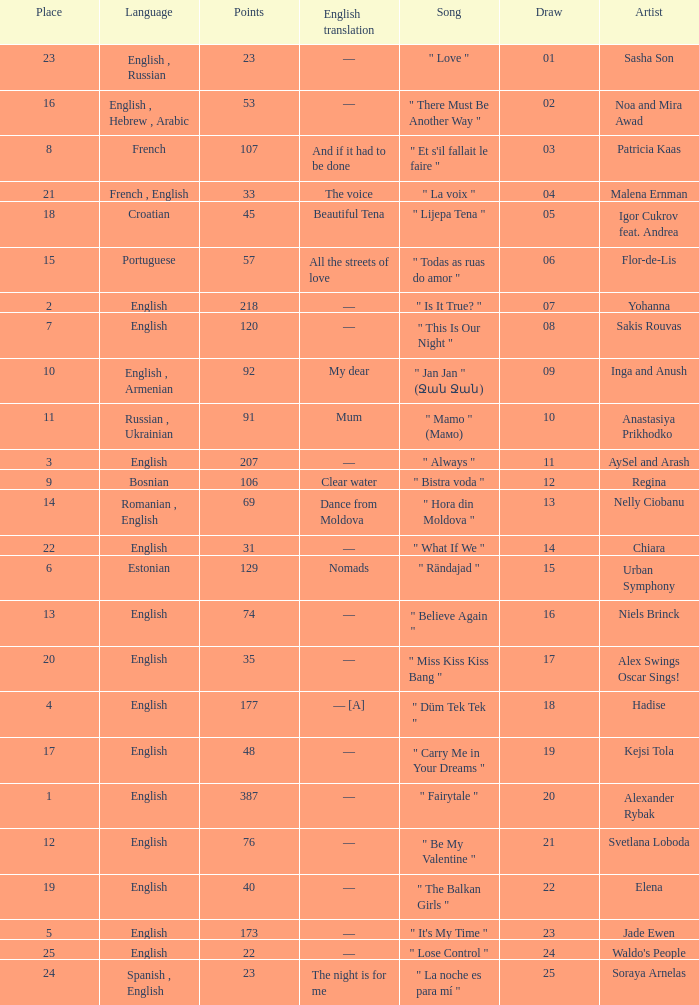Would you be able to parse every entry in this table? {'header': ['Place', 'Language', 'Points', 'English translation', 'Song', 'Draw', 'Artist'], 'rows': [['23', 'English , Russian', '23', '—', '" Love "', '01', 'Sasha Son'], ['16', 'English , Hebrew , Arabic', '53', '—', '" There Must Be Another Way "', '02', 'Noa and Mira Awad'], ['8', 'French', '107', 'And if it had to be done', '" Et s\'il fallait le faire "', '03', 'Patricia Kaas'], ['21', 'French , English', '33', 'The voice', '" La voix "', '04', 'Malena Ernman'], ['18', 'Croatian', '45', 'Beautiful Tena', '" Lijepa Tena "', '05', 'Igor Cukrov feat. Andrea'], ['15', 'Portuguese', '57', 'All the streets of love', '" Todas as ruas do amor "', '06', 'Flor-de-Lis'], ['2', 'English', '218', '—', '" Is It True? "', '07', 'Yohanna'], ['7', 'English', '120', '—', '" This Is Our Night "', '08', 'Sakis Rouvas'], ['10', 'English , Armenian', '92', 'My dear', '" Jan Jan " (Ջան Ջան)', '09', 'Inga and Anush'], ['11', 'Russian , Ukrainian', '91', 'Mum', '" Mamo " (Мамо)', '10', 'Anastasiya Prikhodko'], ['3', 'English', '207', '—', '" Always "', '11', 'AySel and Arash'], ['9', 'Bosnian', '106', 'Clear water', '" Bistra voda "', '12', 'Regina'], ['14', 'Romanian , English', '69', 'Dance from Moldova', '" Hora din Moldova "', '13', 'Nelly Ciobanu'], ['22', 'English', '31', '—', '" What If We "', '14', 'Chiara'], ['6', 'Estonian', '129', 'Nomads', '" Rändajad "', '15', 'Urban Symphony'], ['13', 'English', '74', '—', '" Believe Again "', '16', 'Niels Brinck'], ['20', 'English', '35', '—', '" Miss Kiss Kiss Bang "', '17', 'Alex Swings Oscar Sings!'], ['4', 'English', '177', '— [A]', '" Düm Tek Tek "', '18', 'Hadise'], ['17', 'English', '48', '—', '" Carry Me in Your Dreams "', '19', 'Kejsi Tola'], ['1', 'English', '387', '—', '" Fairytale "', '20', 'Alexander Rybak'], ['12', 'English', '76', '—', '" Be My Valentine "', '21', 'Svetlana Loboda'], ['19', 'English', '40', '—', '" The Balkan Girls "', '22', 'Elena'], ['5', 'English', '173', '—', '" It\'s My Time "', '23', 'Jade Ewen'], ['25', 'English', '22', '—', '" Lose Control "', '24', "Waldo's People"], ['24', 'Spanish , English', '23', 'The night is for me', '" La noche es para mí "', '25', 'Soraya Arnelas']]} What was the average place for the song that had 69 points and a draw smaller than 13? None. 